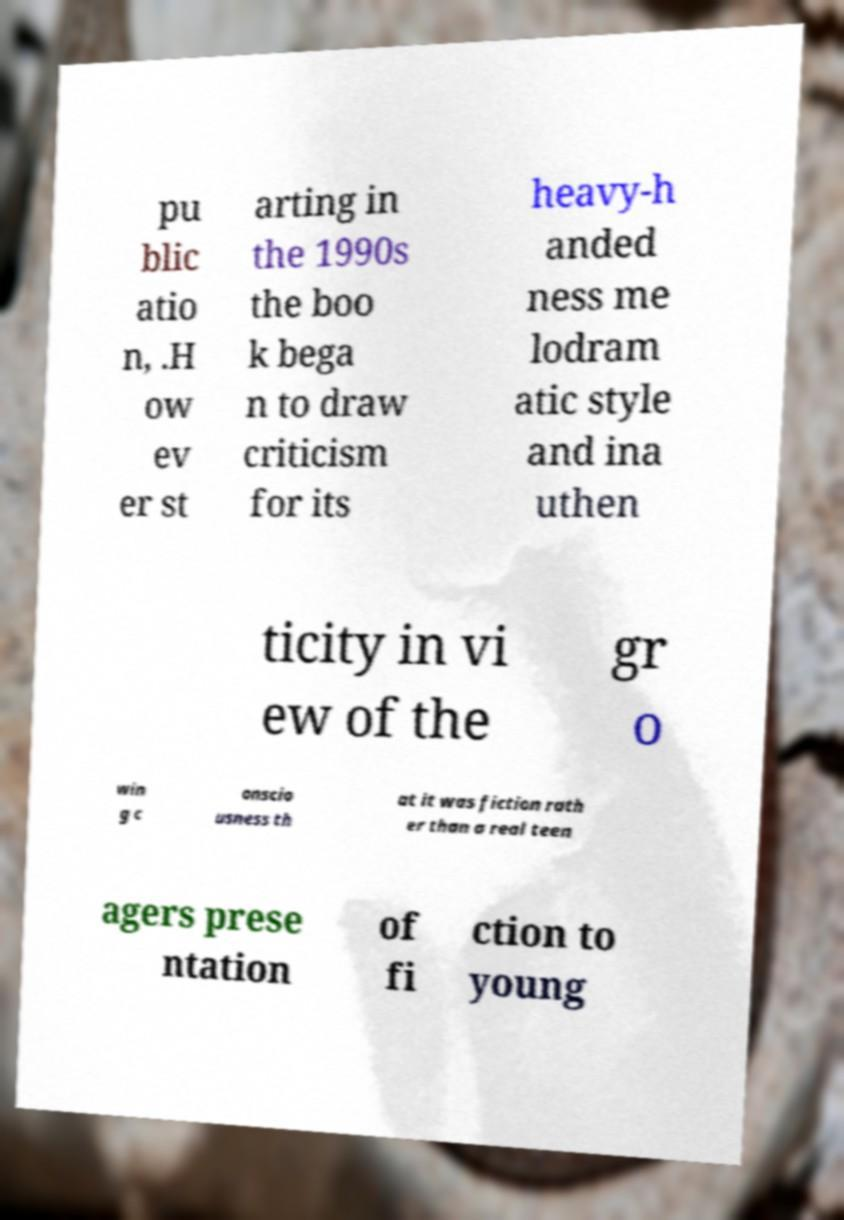For documentation purposes, I need the text within this image transcribed. Could you provide that? pu blic atio n, .H ow ev er st arting in the 1990s the boo k bega n to draw criticism for its heavy-h anded ness me lodram atic style and ina uthen ticity in vi ew of the gr o win g c onscio usness th at it was fiction rath er than a real teen agers prese ntation of fi ction to young 